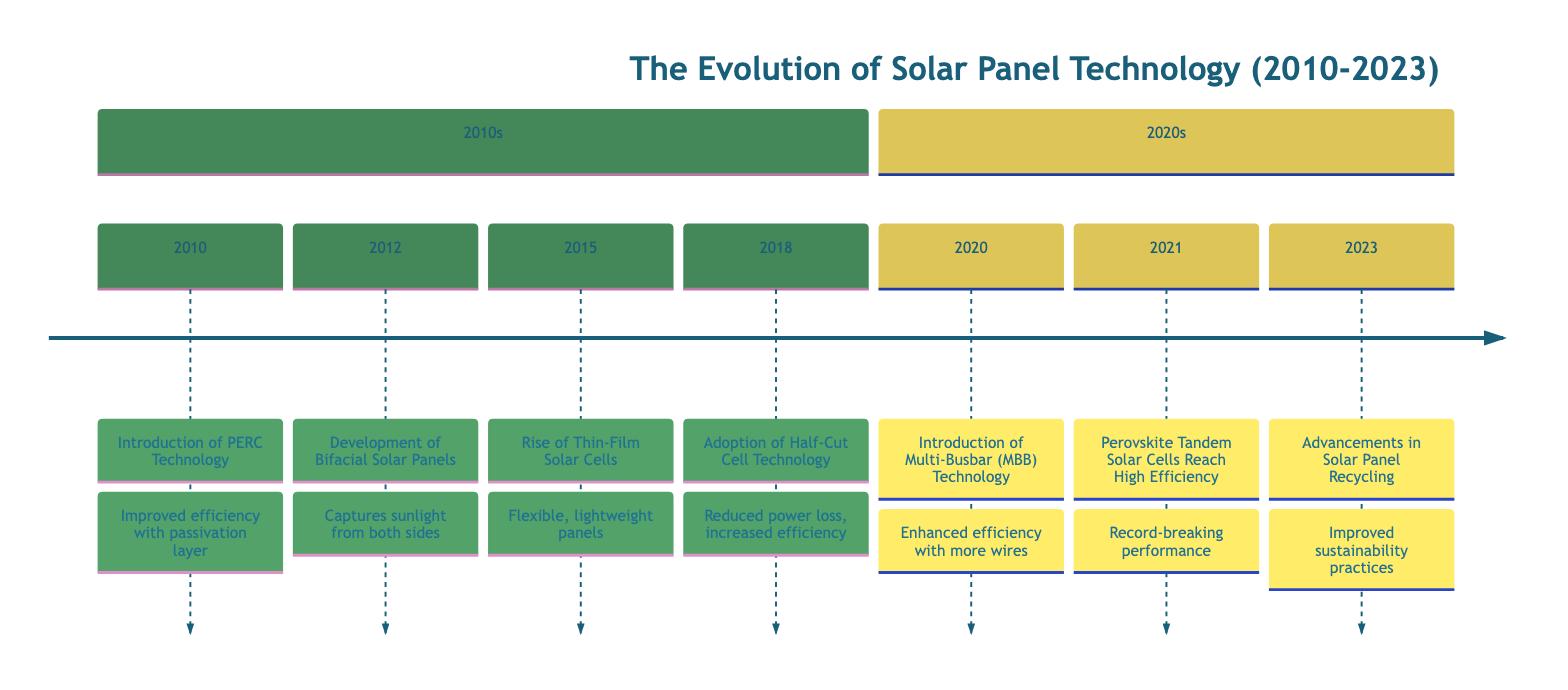What significant solar technology was introduced in 2010? The diagram indicates that in 2010, PERC Technology was introduced, which refers to Passivated Emitter and Rear Cell technology.
Answer: PERC Technology How many key innovations are listed in the timeline? Counting the innovations from the timeline, there are a total of 7 key innovations from 2010 to 2023.
Answer: 7 Which technology was developed in 2015? Looking at the diagram, the technology that was highlighted for development in 2015 is Thin-Film Solar Cells.
Answer: Thin-Film Solar Cells In what year did the advancements in solar panel recycling occur? Referring to the timeline, advancements in solar panel recycling happened in 2023, as indicated by the final entry.
Answer: 2023 What impact did Multi-Busbar technology have on solar panels? The timeline specifies that Multi-Busbar technology increased overall module efficiency and reliability, contributing to a reduced Levelized Cost of Energy.
Answer: Increased efficiency and reduced LCOE Which technology achieved record-high efficiencies in 2021? The entry for the year 2021 in the timeline shows that Perovskite Tandem Solar Cells reached high efficiencies, surpassing traditional silicon cells.
Answer: Perovskite Tandem Solar Cells What is the earliest innovation listed in the diagram? The earliest innovation listed in the timeline is from 2010, which introduces PERC Technology as the first entry.
Answer: PERC Technology What advantage did bifacial solar panels provide when they were introduced? The description for bifacial solar panels in 2012 states that they effectively increased overall energy production by capturing sunlight from both sides.
Answer: Increased overall energy production Which technology focused on reducing power loss and increasing efficiency? The timeline reveals that the adoption of Half-Cut Cell Technology in 2018 focused on reducing power loss and increasing efficiency in solar panels.
Answer: Half-Cut Cell Technology 